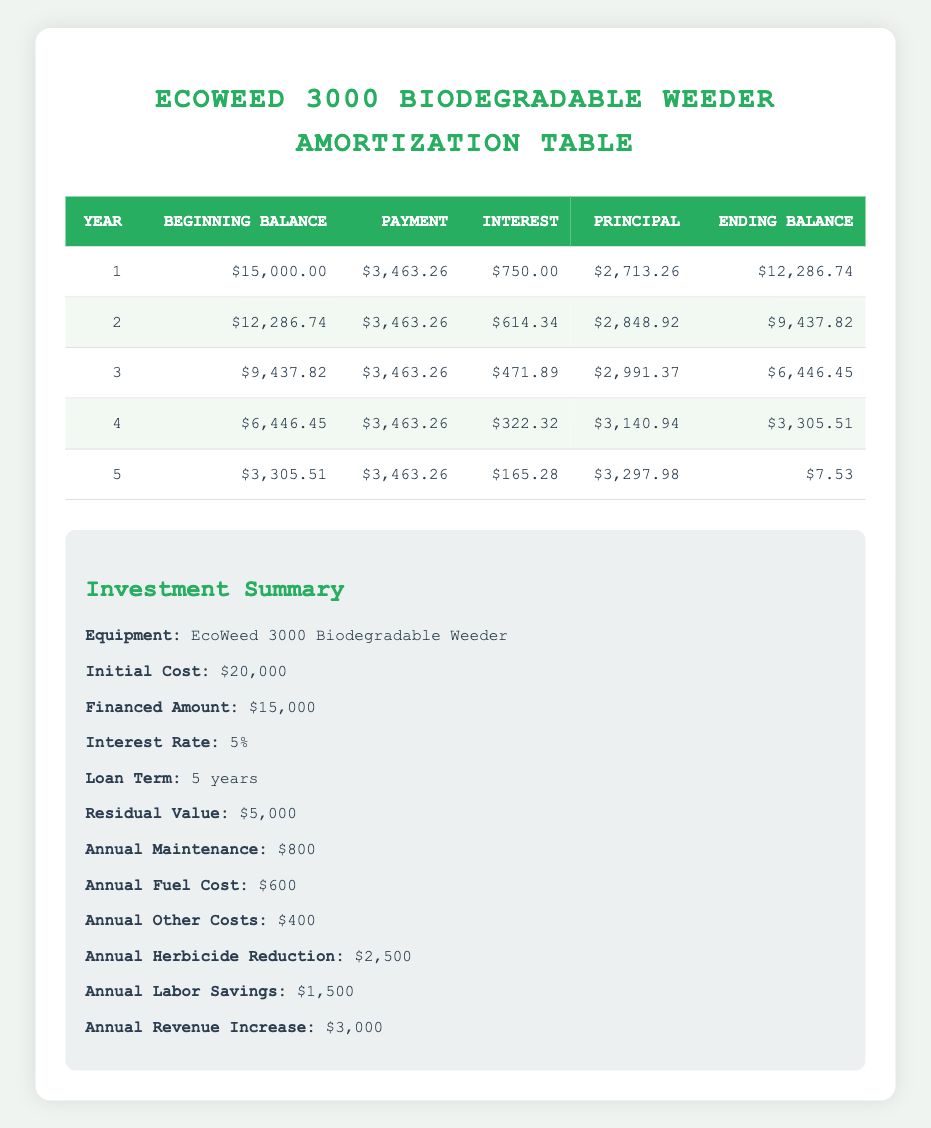What is the total amount paid in each of the first 5 years? To find the total amount paid each year, I will refer to the "Payment" column of the table. The amounts are: Year 1: 3463.26, Year 2: 3463.26, Year 3: 3463.26, Year 4: 3463.26, Year 5: 3463.26. Adding them gives 3463.26 * 5 = 17316.30.
Answer: 17316.30 How much interest is paid in the second year? The interest paid in the second year can be found in the "Interest" column for Year 2, which shows 614.34.
Answer: 614.34 What is the total principal paid off after 3 years? To find the total principal paid after 3 years, I need to look at the "Principal" column for Years 1, 2, and 3. The amounts are: Year 1: 2713.26, Year 2: 2848.92, Year 3: 2991.37. Adding them gives 2713.26 + 2848.92 + 2991.37 = 8553.55.
Answer: 8553.55 Is the ending balance after 5 years less than the residual value? The ending balance after 5 years is listed in the table as 7.53. The residual value is 5000. Since 7.53 is less than 5000, the statement is true.
Answer: True How much total interest will be paid after the entire loan period? To find the total interest paid, I will sum the interest paid each year: Year 1: 750.00, Year 2: 614.34, Year 3: 471.89, Year 4: 322.32, Year 5: 165.28. Adding gives 750 + 614.34 + 471.89 + 322.32 + 165.28 = 2324.83.
Answer: 2324.83 What is the average annual saving from herbicide reduction and labor savings combined? First, combine the annual savings: herbicide reduction is 2500 and labor savings is 1500. Total savings = 2500 + 1500 = 4000. Since this is an annual saving, the average equals 4000 as well.
Answer: 4000 How much is the remaining unpaid principal at the end of Year 4? According to the table, the ending balance after Year 4 is 3305.51, which represents the unpaid principal at that time.
Answer: 3305.51 What is the total cost of operation each year, including maintenance and fuel costs? To compute the total annual operational costs, I add annual maintenance (800), annual fuel cost (600), and annual other costs (400): 800 + 600 + 400 = 1800.
Answer: 1800 What is the principal payment in the fourth year? The principal payment for Year 4 can be found in the table; it is listed as 3140.94 in the "Principal" column for that year.
Answer: 3140.94 